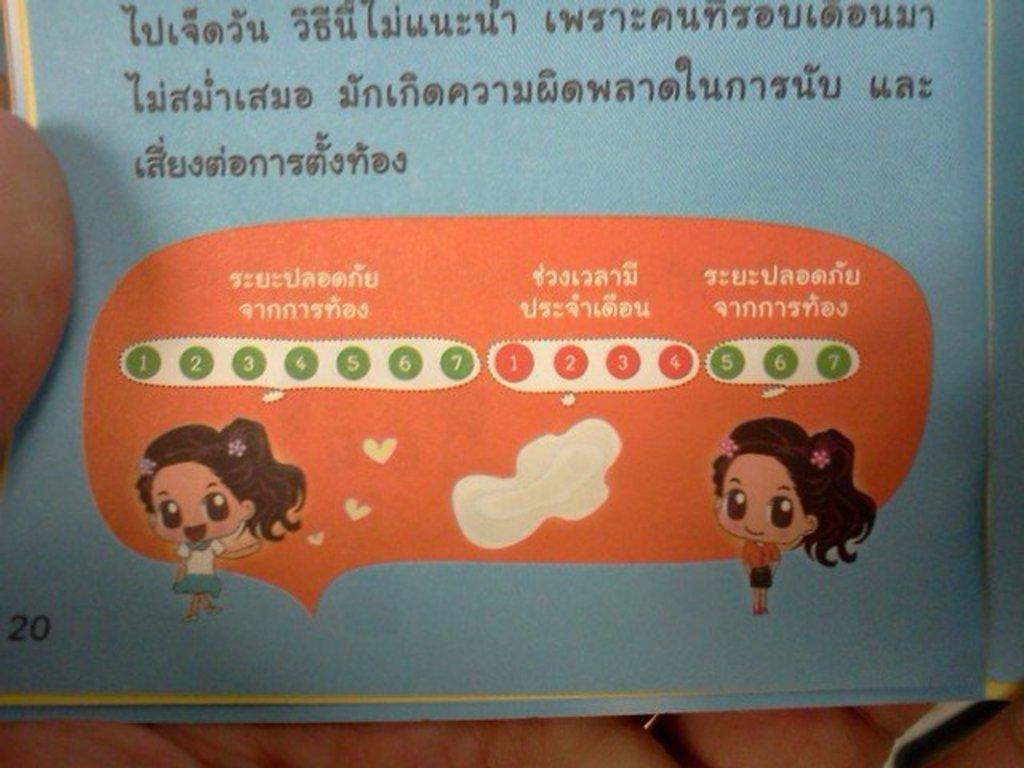What is the person's hand holding in the image? The person's hand is holding a paper in the image. What type of information is on the paper? The paper contains text, numbers, and pictures. Can you describe the content of the paper in more detail? The text, numbers, and pictures on the paper are not specified in the facts provided. What is the weather like in space, as depicted in the image? There is no reference to space or weather in the image, as it features a person's hand holding a paper with text, numbers, and pictures. 